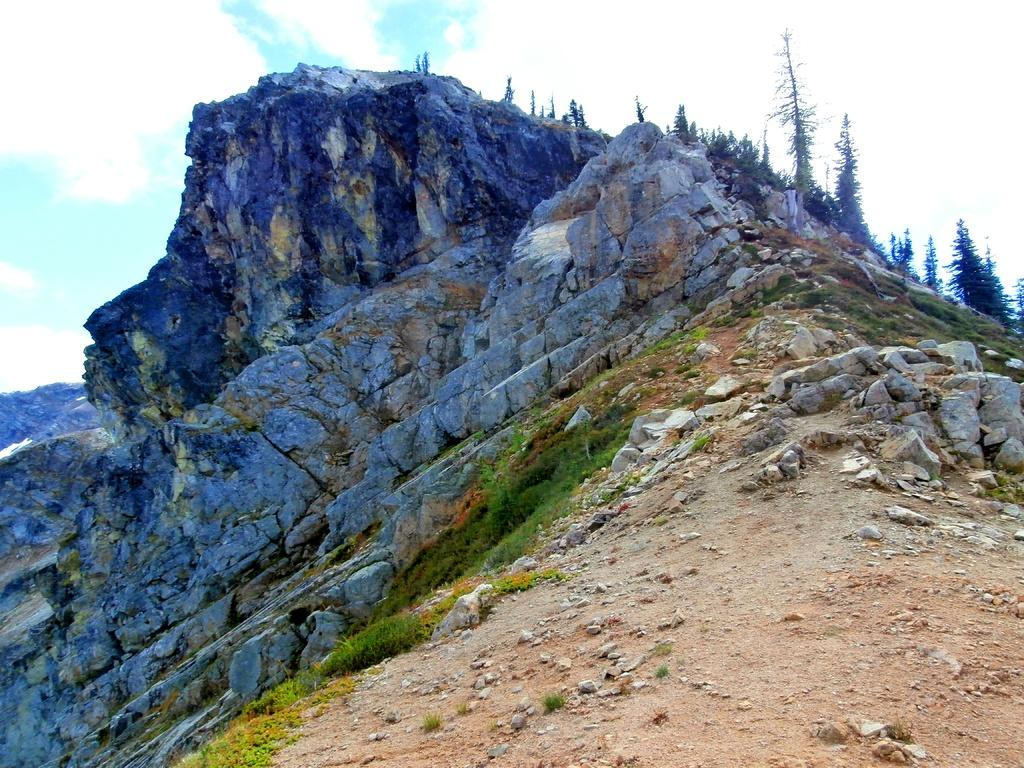What type of vegetation is in the foreground of the image? There is grass in the foreground of the image. What geographical features are in the foreground of the image? There are mountains and trees in the foreground of the image. What can be seen in the background of the image? The sky is visible in the background of the image. What time of day might the image have been taken? The image appears to have been taken during the day. What type of record can be seen in the image? There is no record present in the image. Is there any toothpaste visible on the trees in the image? There is no toothpaste present in the image. 